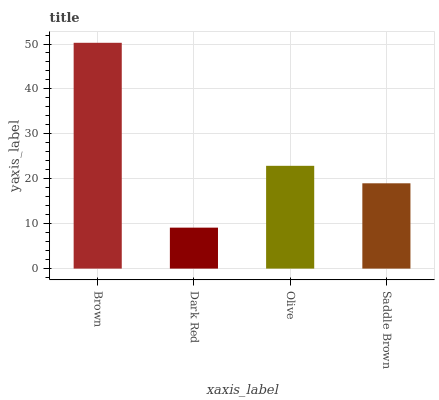Is Dark Red the minimum?
Answer yes or no. Yes. Is Brown the maximum?
Answer yes or no. Yes. Is Olive the minimum?
Answer yes or no. No. Is Olive the maximum?
Answer yes or no. No. Is Olive greater than Dark Red?
Answer yes or no. Yes. Is Dark Red less than Olive?
Answer yes or no. Yes. Is Dark Red greater than Olive?
Answer yes or no. No. Is Olive less than Dark Red?
Answer yes or no. No. Is Olive the high median?
Answer yes or no. Yes. Is Saddle Brown the low median?
Answer yes or no. Yes. Is Dark Red the high median?
Answer yes or no. No. Is Brown the low median?
Answer yes or no. No. 